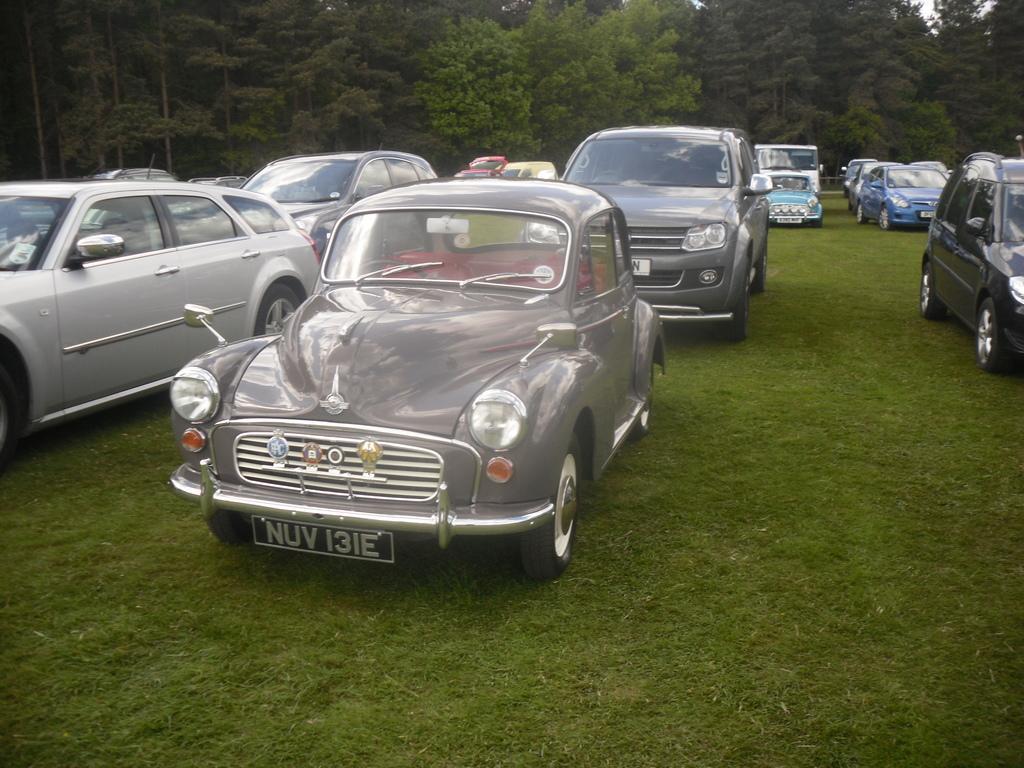Could you give a brief overview of what you see in this image? In this image we can see so many cars are parked on the green land. Background of the image trees are present. 